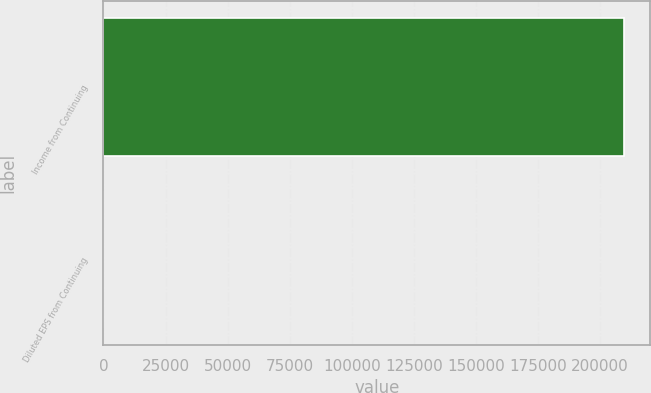Convert chart to OTSL. <chart><loc_0><loc_0><loc_500><loc_500><bar_chart><fcel>Income from Continuing<fcel>Diluted EPS from Continuing<nl><fcel>209658<fcel>0.66<nl></chart> 